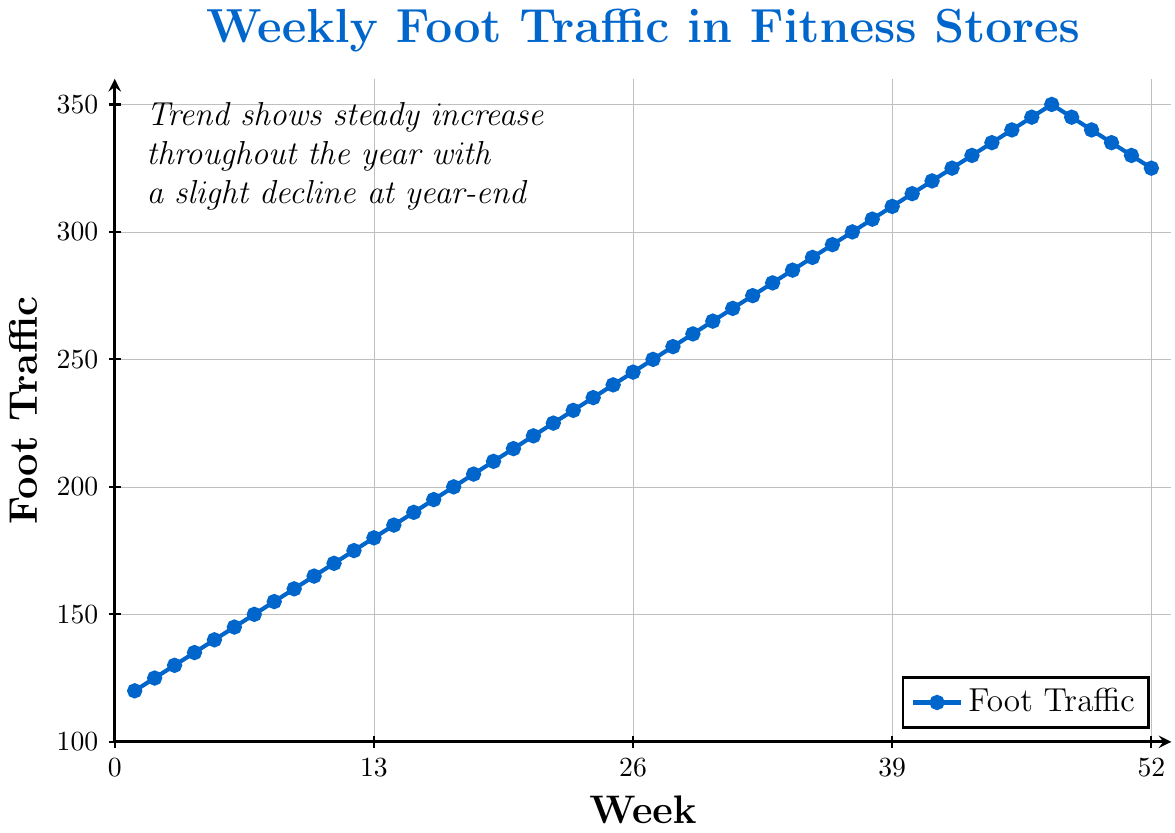What's the highest foot traffic shown in the chart? To find the highest foot traffic, look for the highest point on the line plot which corresponds to the maximum foot traffic. It occurs at week 47 with a value of 350.
Answer: 350 Does the foot traffic ever decrease during the year? To see if the foot traffic decreases, observe the trend of the line. Initially, the line rises steadily but shows a downward dip after week 47.
Answer: Yes What is the foot traffic at week 26? Locate week 26 on the x-axis and find the corresponding y-value, which indicates foot traffic. For week 26, the foot traffic is 245.
Answer: 245 How many weeks did foot traffic remain stable or decrease? Count the weeks where the line is horizontal or decreasing. This happens from week 48 to week 52, a total of 5 weeks.
Answer: 5 weeks Which week shows the first decline in foot traffic? To find the first week showing a decline, observe the line and identify the point where it first dips after constantly increasing. It first declines after week 47.
Answer: Week 48 What is the average foot traffic for the first 10 weeks? Add the foot traffic from week 1 to week 10 and then divide by 10: (120 + 125 + 130 + 135 + 140 + 145 + 150 + 155 + 160 + 165) / 10 = 1425 / 10 = 142.5.
Answer: 142.5 Between which weeks does the greatest increase in foot traffic occur? To find the greatest increase, compute the differences between consecutive weeks. The largest jump occurs from week 46 to week 47, where it increases from 345 to 350.
Answer: Week 46 to Week 47 What color represents the line and data points in the chart? Observe the color of the line and markers; the line is blue, and the data points are orange.
Answer: Blue, Orange How does foot traffic trend in the final month? Look at the last 4 weeks (weeks 49 to 52). The traffic decreases from 345 to 325, indicating a downward trend.
Answer: Downward trend Does the chart have a legend, and if so, what does it represent? Check for the presence of a legend and examine what it signifies. The legend is present and it represents 'Foot Traffic'.
Answer: Yes, Foot Traffic 